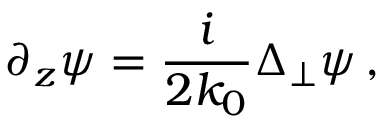Convert formula to latex. <formula><loc_0><loc_0><loc_500><loc_500>\partial _ { z } \psi = \frac { i } { 2 k _ { 0 } } \Delta _ { \perp } \psi \, ,</formula> 